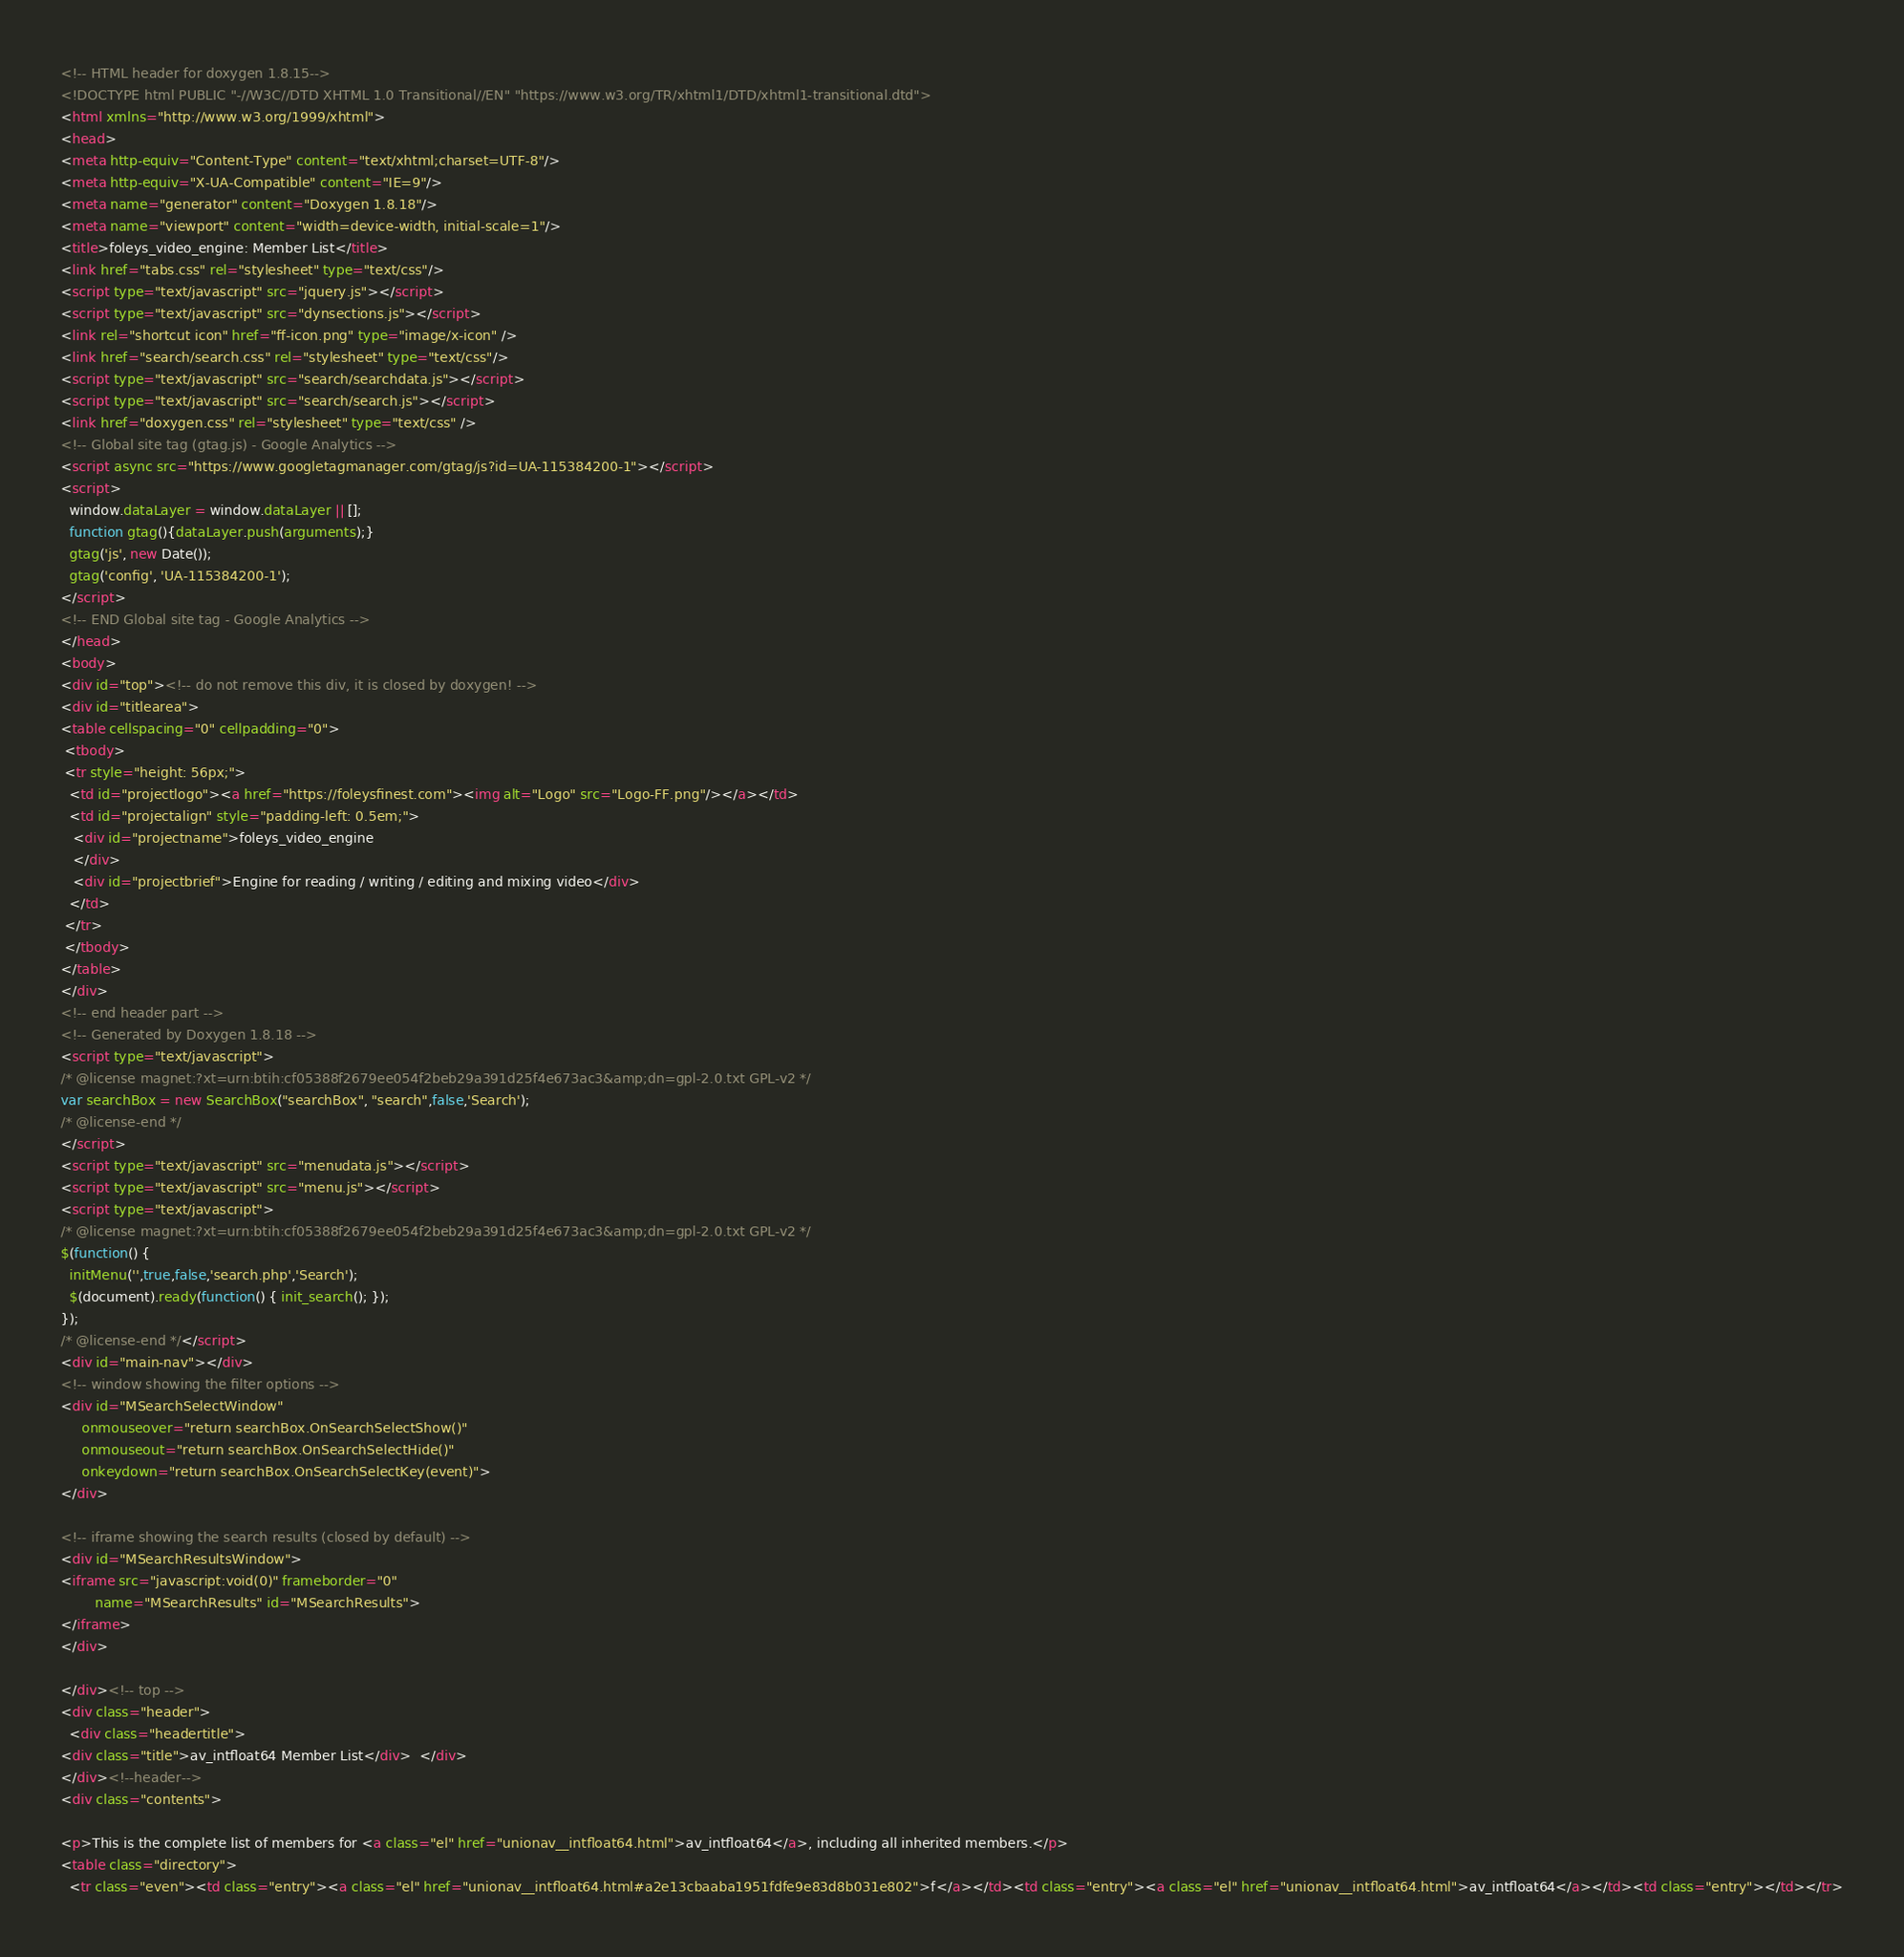Convert code to text. <code><loc_0><loc_0><loc_500><loc_500><_HTML_><!-- HTML header for doxygen 1.8.15-->
<!DOCTYPE html PUBLIC "-//W3C//DTD XHTML 1.0 Transitional//EN" "https://www.w3.org/TR/xhtml1/DTD/xhtml1-transitional.dtd">
<html xmlns="http://www.w3.org/1999/xhtml">
<head>
<meta http-equiv="Content-Type" content="text/xhtml;charset=UTF-8"/>
<meta http-equiv="X-UA-Compatible" content="IE=9"/>
<meta name="generator" content="Doxygen 1.8.18"/>
<meta name="viewport" content="width=device-width, initial-scale=1"/>
<title>foleys_video_engine: Member List</title>
<link href="tabs.css" rel="stylesheet" type="text/css"/>
<script type="text/javascript" src="jquery.js"></script>
<script type="text/javascript" src="dynsections.js"></script>
<link rel="shortcut icon" href="ff-icon.png" type="image/x-icon" />
<link href="search/search.css" rel="stylesheet" type="text/css"/>
<script type="text/javascript" src="search/searchdata.js"></script>
<script type="text/javascript" src="search/search.js"></script>
<link href="doxygen.css" rel="stylesheet" type="text/css" />
<!-- Global site tag (gtag.js) - Google Analytics -->
<script async src="https://www.googletagmanager.com/gtag/js?id=UA-115384200-1"></script>
<script>
  window.dataLayer = window.dataLayer || [];
  function gtag(){dataLayer.push(arguments);}
  gtag('js', new Date());
  gtag('config', 'UA-115384200-1');
</script>
<!-- END Global site tag - Google Analytics -->
</head>
<body>
<div id="top"><!-- do not remove this div, it is closed by doxygen! -->
<div id="titlearea">
<table cellspacing="0" cellpadding="0">
 <tbody>
 <tr style="height: 56px;">
  <td id="projectlogo"><a href="https://foleysfinest.com"><img alt="Logo" src="Logo-FF.png"/></a></td>
  <td id="projectalign" style="padding-left: 0.5em;">
   <div id="projectname">foleys_video_engine
   </div>
   <div id="projectbrief">Engine for reading / writing / editing and mixing video</div>
  </td>
 </tr>
 </tbody>
</table>
</div>
<!-- end header part -->
<!-- Generated by Doxygen 1.8.18 -->
<script type="text/javascript">
/* @license magnet:?xt=urn:btih:cf05388f2679ee054f2beb29a391d25f4e673ac3&amp;dn=gpl-2.0.txt GPL-v2 */
var searchBox = new SearchBox("searchBox", "search",false,'Search');
/* @license-end */
</script>
<script type="text/javascript" src="menudata.js"></script>
<script type="text/javascript" src="menu.js"></script>
<script type="text/javascript">
/* @license magnet:?xt=urn:btih:cf05388f2679ee054f2beb29a391d25f4e673ac3&amp;dn=gpl-2.0.txt GPL-v2 */
$(function() {
  initMenu('',true,false,'search.php','Search');
  $(document).ready(function() { init_search(); });
});
/* @license-end */</script>
<div id="main-nav"></div>
<!-- window showing the filter options -->
<div id="MSearchSelectWindow"
     onmouseover="return searchBox.OnSearchSelectShow()"
     onmouseout="return searchBox.OnSearchSelectHide()"
     onkeydown="return searchBox.OnSearchSelectKey(event)">
</div>

<!-- iframe showing the search results (closed by default) -->
<div id="MSearchResultsWindow">
<iframe src="javascript:void(0)" frameborder="0" 
        name="MSearchResults" id="MSearchResults">
</iframe>
</div>

</div><!-- top -->
<div class="header">
  <div class="headertitle">
<div class="title">av_intfloat64 Member List</div>  </div>
</div><!--header-->
<div class="contents">

<p>This is the complete list of members for <a class="el" href="unionav__intfloat64.html">av_intfloat64</a>, including all inherited members.</p>
<table class="directory">
  <tr class="even"><td class="entry"><a class="el" href="unionav__intfloat64.html#a2e13cbaaba1951fdfe9e83d8b031e802">f</a></td><td class="entry"><a class="el" href="unionav__intfloat64.html">av_intfloat64</a></td><td class="entry"></td></tr></code> 